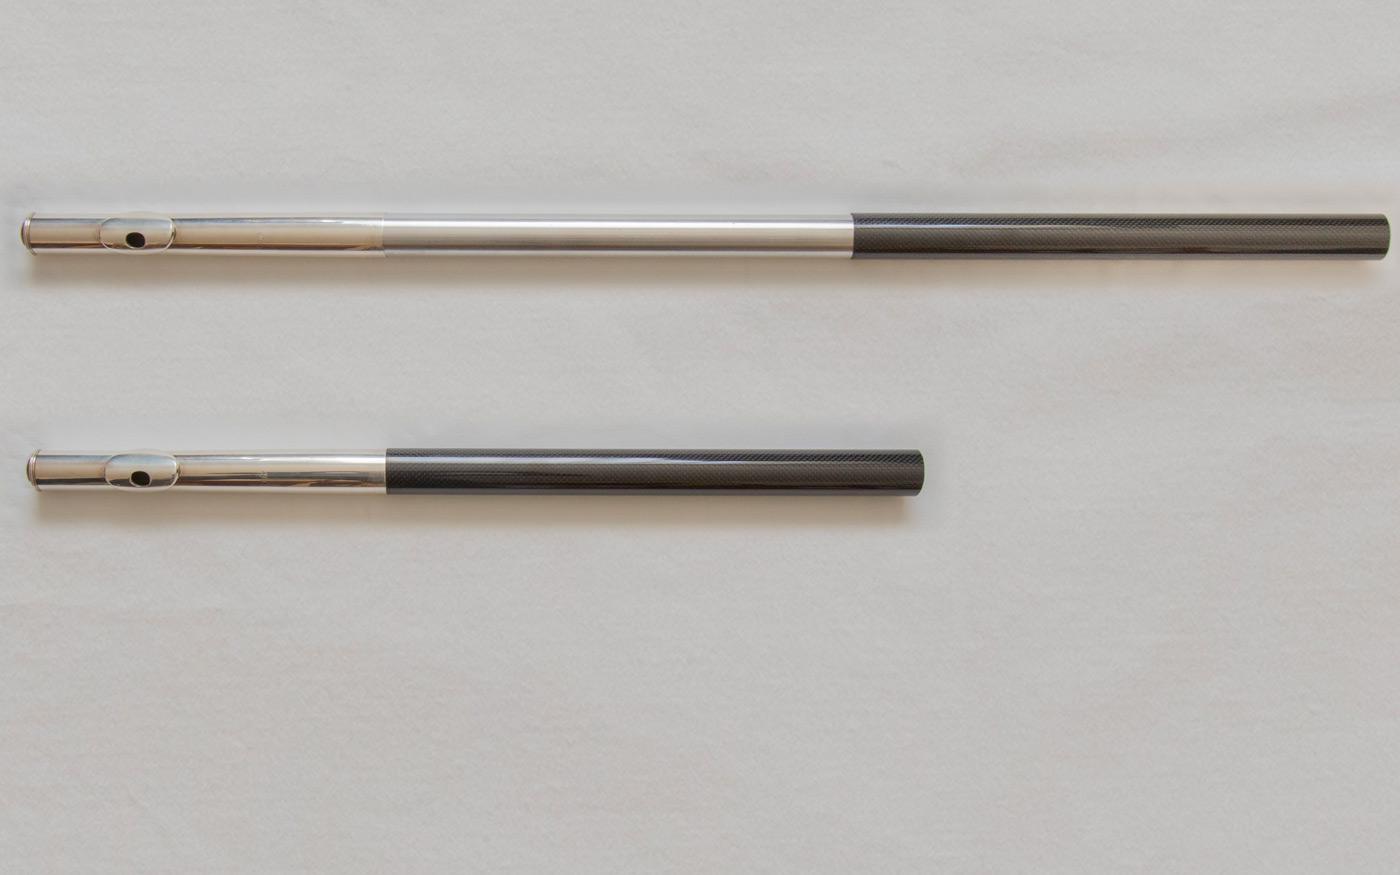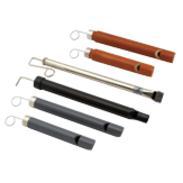The first image is the image on the left, the second image is the image on the right. Considering the images on both sides, is "The right image contains a single instrument." valid? Answer yes or no. No. The first image is the image on the left, the second image is the image on the right. Given the left and right images, does the statement "Each image contains a single instrument item, and at least one image shows a part with two metal tabs extending around an oblong hole." hold true? Answer yes or no. No. 